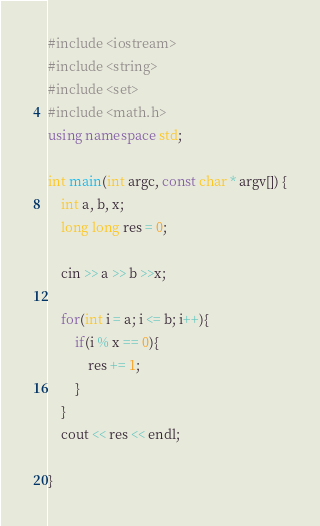<code> <loc_0><loc_0><loc_500><loc_500><_C++_>#include <iostream>
#include <string>
#include <set>
#include <math.h>
using namespace std;

int main(int argc, const char * argv[]) {
    int a, b, x;
    long long res = 0;

    cin >> a >> b >>x;

    for(int i = a; i <= b; i++){
        if(i % x == 0){
            res += 1;
        }
    }
    cout << res << endl;

}</code> 